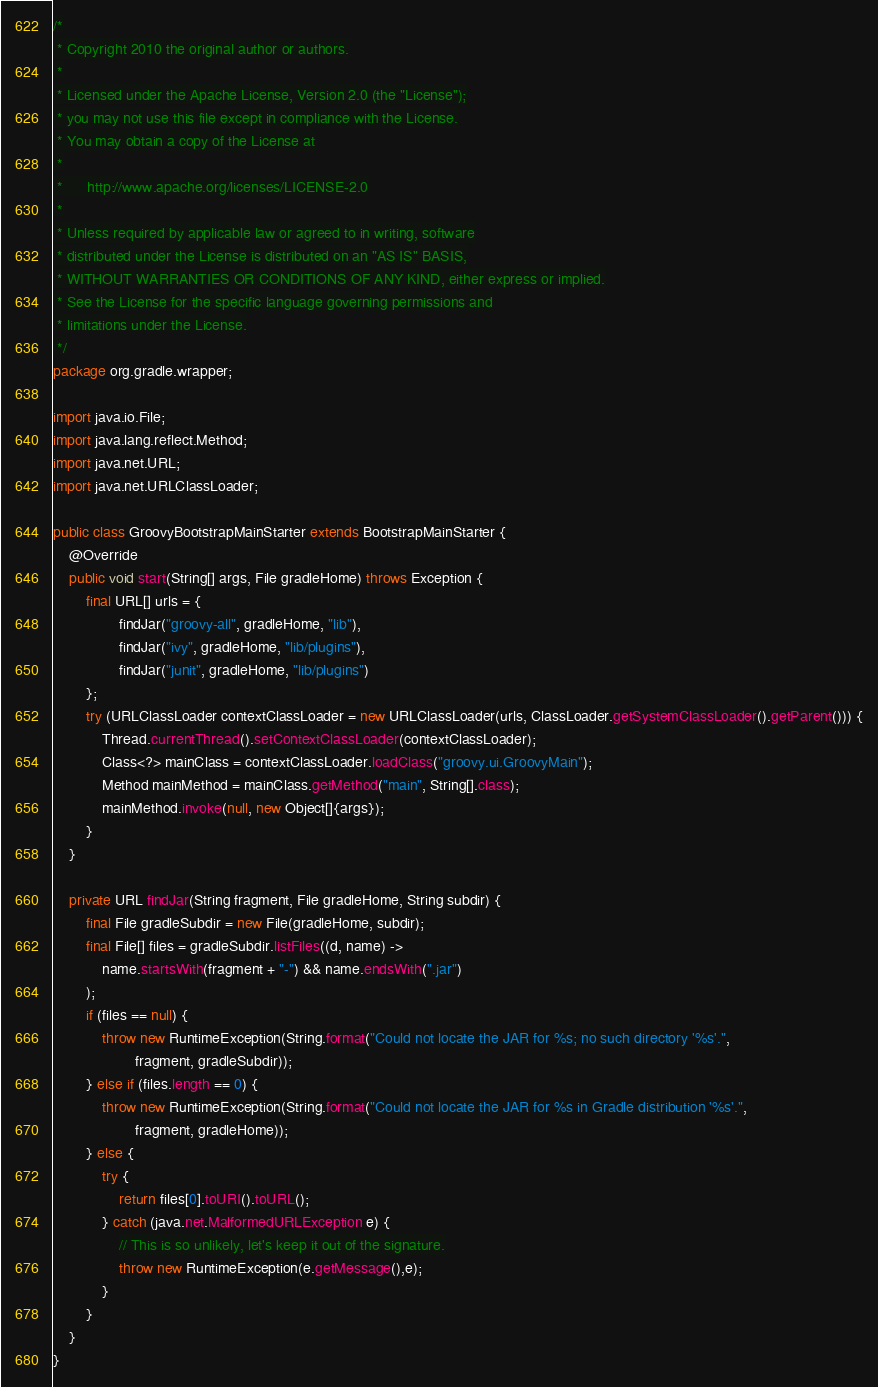<code> <loc_0><loc_0><loc_500><loc_500><_Java_>/*
 * Copyright 2010 the original author or authors.
 *
 * Licensed under the Apache License, Version 2.0 (the "License");
 * you may not use this file except in compliance with the License.
 * You may obtain a copy of the License at
 *
 *      http://www.apache.org/licenses/LICENSE-2.0
 *
 * Unless required by applicable law or agreed to in writing, software
 * distributed under the License is distributed on an "AS IS" BASIS,
 * WITHOUT WARRANTIES OR CONDITIONS OF ANY KIND, either express or implied.
 * See the License for the specific language governing permissions and
 * limitations under the License.
 */
package org.gradle.wrapper;

import java.io.File;
import java.lang.reflect.Method;
import java.net.URL;
import java.net.URLClassLoader;

public class GroovyBootstrapMainStarter extends BootstrapMainStarter {
    @Override
    public void start(String[] args, File gradleHome) throws Exception {
        final URL[] urls = {
                findJar("groovy-all", gradleHome, "lib"),
                findJar("ivy", gradleHome, "lib/plugins"),
                findJar("junit", gradleHome, "lib/plugins")
        };
        try (URLClassLoader contextClassLoader = new URLClassLoader(urls, ClassLoader.getSystemClassLoader().getParent())) {
            Thread.currentThread().setContextClassLoader(contextClassLoader);
            Class<?> mainClass = contextClassLoader.loadClass("groovy.ui.GroovyMain");
            Method mainMethod = mainClass.getMethod("main", String[].class);
            mainMethod.invoke(null, new Object[]{args});
        }
    }

    private URL findJar(String fragment, File gradleHome, String subdir) {
        final File gradleSubdir = new File(gradleHome, subdir);
        final File[] files = gradleSubdir.listFiles((d, name) ->
            name.startsWith(fragment + "-") && name.endsWith(".jar")
        );
        if (files == null) {
            throw new RuntimeException(String.format("Could not locate the JAR for %s; no such directory '%s'.",
                    fragment, gradleSubdir));
        } else if (files.length == 0) {
            throw new RuntimeException(String.format("Could not locate the JAR for %s in Gradle distribution '%s'.",
                    fragment, gradleHome));
        } else {
            try {
                return files[0].toURI().toURL();
            } catch (java.net.MalformedURLException e) {
                // This is so unlikely, let's keep it out of the signature.
                throw new RuntimeException(e.getMessage(),e);
            }
        }
    }
}
</code> 